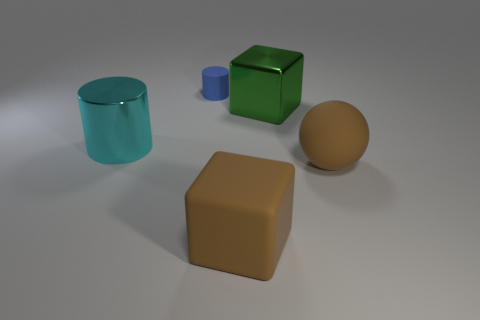Is there any other thing that is the same size as the matte cylinder?
Keep it short and to the point. No. Is the number of big rubber balls in front of the matte cylinder less than the number of rubber objects in front of the big cyan cylinder?
Your response must be concise. Yes. How many matte blocks have the same color as the large rubber sphere?
Keep it short and to the point. 1. How many brown matte objects are both in front of the brown ball and behind the matte cube?
Provide a succinct answer. 0. There is a cylinder left of the matte object that is behind the brown rubber ball; what is it made of?
Keep it short and to the point. Metal. Is there a green cube made of the same material as the big cyan object?
Provide a short and direct response. Yes. What is the material of the brown sphere that is the same size as the cyan object?
Offer a terse response. Rubber. There is a cylinder that is behind the big cube that is behind the brown matte object left of the large green shiny block; what is its size?
Offer a terse response. Small. There is a cylinder in front of the small blue matte thing; is there a shiny thing behind it?
Offer a terse response. Yes. There is a tiny blue matte object; is its shape the same as the metallic object right of the tiny blue matte thing?
Your response must be concise. No. 